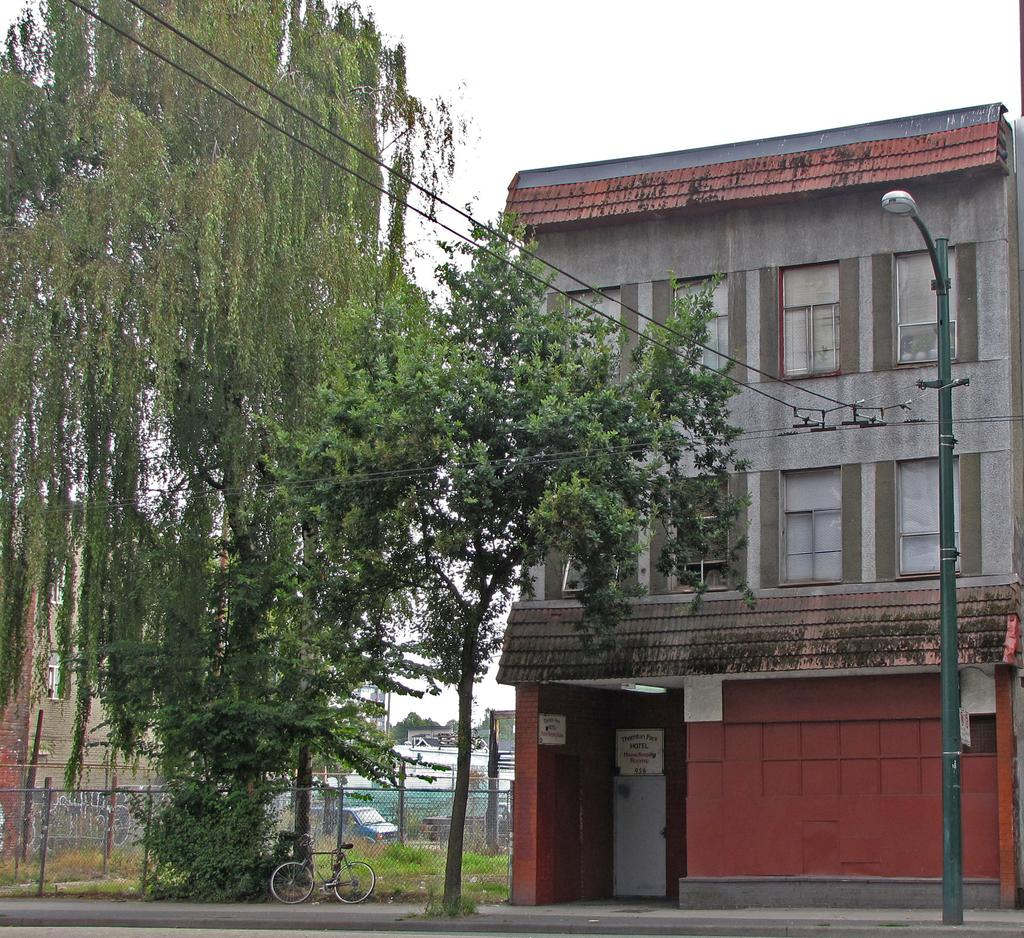What type of structures can be seen in the image? There are houses in the image. What other natural elements are present in the image? There are trees in the image. What type of barrier can be seen in the image? There is fencing in the image. What mode of transportation is visible in the image? There is a bicycle in the image. What type of man-made structure is present in the image? There is a light pole in the image. What part of the natural environment is visible in the image? The sky is visible at the top of the image. What type of surface is visible at the bottom of the image? There is a road visible at the bottom of the image. How many chickens are crossing the road in the image? There are no chickens present in the image, and therefore no such activity can be observed. What type of bell can be heard ringing in the image? There is no bell present in the image, and therefore no sound can be heard. 